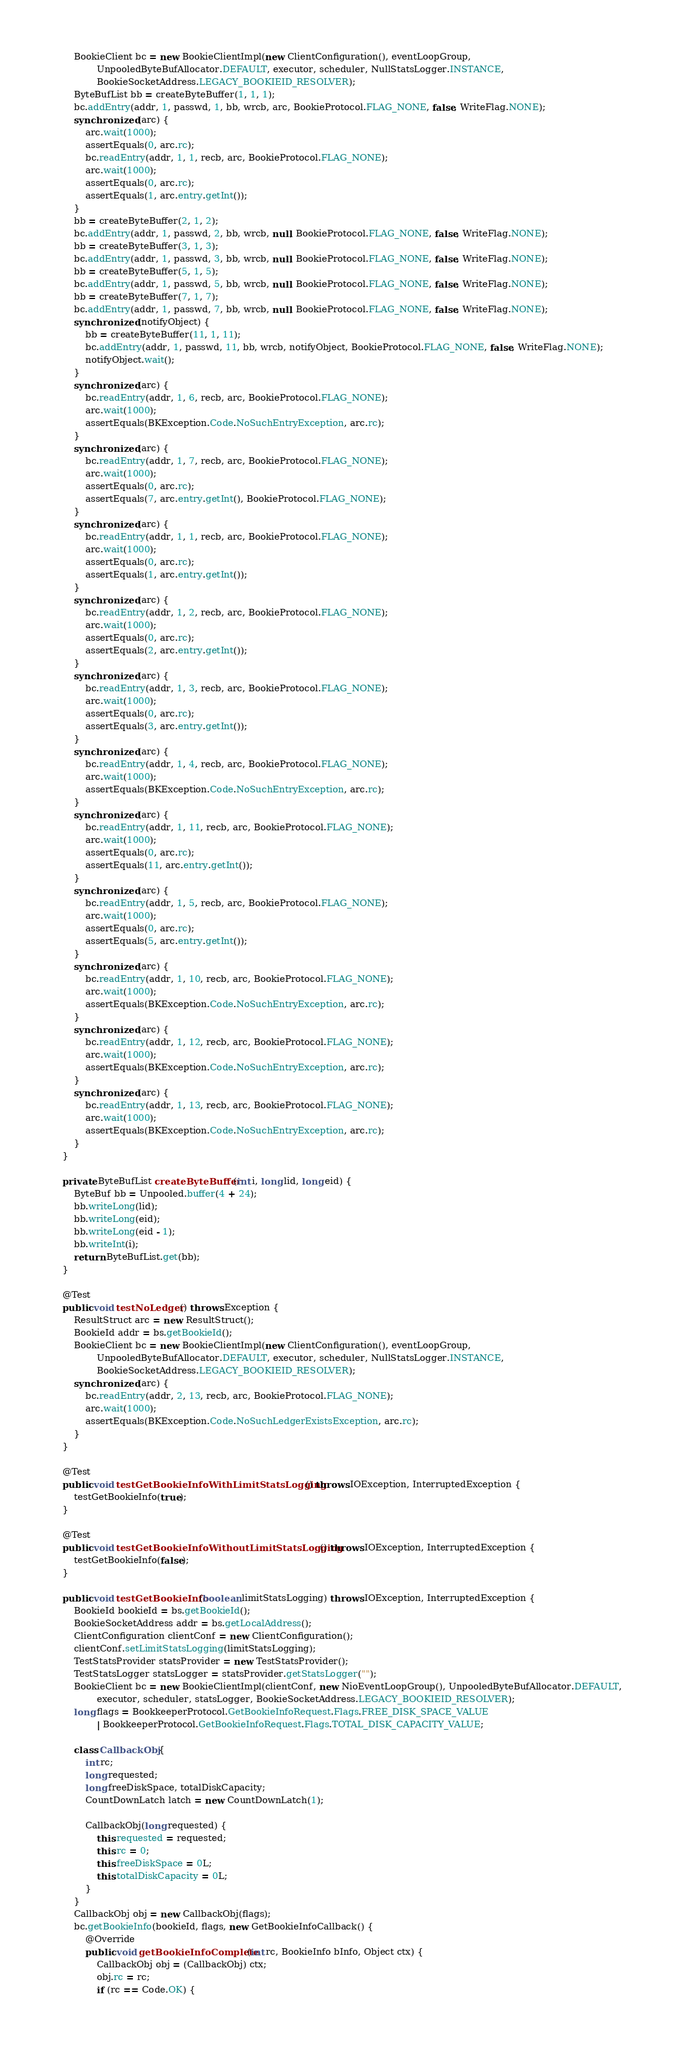Convert code to text. <code><loc_0><loc_0><loc_500><loc_500><_Java_>
        BookieClient bc = new BookieClientImpl(new ClientConfiguration(), eventLoopGroup,
                UnpooledByteBufAllocator.DEFAULT, executor, scheduler, NullStatsLogger.INSTANCE,
                BookieSocketAddress.LEGACY_BOOKIEID_RESOLVER);
        ByteBufList bb = createByteBuffer(1, 1, 1);
        bc.addEntry(addr, 1, passwd, 1, bb, wrcb, arc, BookieProtocol.FLAG_NONE, false, WriteFlag.NONE);
        synchronized (arc) {
            arc.wait(1000);
            assertEquals(0, arc.rc);
            bc.readEntry(addr, 1, 1, recb, arc, BookieProtocol.FLAG_NONE);
            arc.wait(1000);
            assertEquals(0, arc.rc);
            assertEquals(1, arc.entry.getInt());
        }
        bb = createByteBuffer(2, 1, 2);
        bc.addEntry(addr, 1, passwd, 2, bb, wrcb, null, BookieProtocol.FLAG_NONE, false, WriteFlag.NONE);
        bb = createByteBuffer(3, 1, 3);
        bc.addEntry(addr, 1, passwd, 3, bb, wrcb, null, BookieProtocol.FLAG_NONE, false, WriteFlag.NONE);
        bb = createByteBuffer(5, 1, 5);
        bc.addEntry(addr, 1, passwd, 5, bb, wrcb, null, BookieProtocol.FLAG_NONE, false, WriteFlag.NONE);
        bb = createByteBuffer(7, 1, 7);
        bc.addEntry(addr, 1, passwd, 7, bb, wrcb, null, BookieProtocol.FLAG_NONE, false, WriteFlag.NONE);
        synchronized (notifyObject) {
            bb = createByteBuffer(11, 1, 11);
            bc.addEntry(addr, 1, passwd, 11, bb, wrcb, notifyObject, BookieProtocol.FLAG_NONE, false, WriteFlag.NONE);
            notifyObject.wait();
        }
        synchronized (arc) {
            bc.readEntry(addr, 1, 6, recb, arc, BookieProtocol.FLAG_NONE);
            arc.wait(1000);
            assertEquals(BKException.Code.NoSuchEntryException, arc.rc);
        }
        synchronized (arc) {
            bc.readEntry(addr, 1, 7, recb, arc, BookieProtocol.FLAG_NONE);
            arc.wait(1000);
            assertEquals(0, arc.rc);
            assertEquals(7, arc.entry.getInt(), BookieProtocol.FLAG_NONE);
        }
        synchronized (arc) {
            bc.readEntry(addr, 1, 1, recb, arc, BookieProtocol.FLAG_NONE);
            arc.wait(1000);
            assertEquals(0, arc.rc);
            assertEquals(1, arc.entry.getInt());
        }
        synchronized (arc) {
            bc.readEntry(addr, 1, 2, recb, arc, BookieProtocol.FLAG_NONE);
            arc.wait(1000);
            assertEquals(0, arc.rc);
            assertEquals(2, arc.entry.getInt());
        }
        synchronized (arc) {
            bc.readEntry(addr, 1, 3, recb, arc, BookieProtocol.FLAG_NONE);
            arc.wait(1000);
            assertEquals(0, arc.rc);
            assertEquals(3, arc.entry.getInt());
        }
        synchronized (arc) {
            bc.readEntry(addr, 1, 4, recb, arc, BookieProtocol.FLAG_NONE);
            arc.wait(1000);
            assertEquals(BKException.Code.NoSuchEntryException, arc.rc);
        }
        synchronized (arc) {
            bc.readEntry(addr, 1, 11, recb, arc, BookieProtocol.FLAG_NONE);
            arc.wait(1000);
            assertEquals(0, arc.rc);
            assertEquals(11, arc.entry.getInt());
        }
        synchronized (arc) {
            bc.readEntry(addr, 1, 5, recb, arc, BookieProtocol.FLAG_NONE);
            arc.wait(1000);
            assertEquals(0, arc.rc);
            assertEquals(5, arc.entry.getInt());
        }
        synchronized (arc) {
            bc.readEntry(addr, 1, 10, recb, arc, BookieProtocol.FLAG_NONE);
            arc.wait(1000);
            assertEquals(BKException.Code.NoSuchEntryException, arc.rc);
        }
        synchronized (arc) {
            bc.readEntry(addr, 1, 12, recb, arc, BookieProtocol.FLAG_NONE);
            arc.wait(1000);
            assertEquals(BKException.Code.NoSuchEntryException, arc.rc);
        }
        synchronized (arc) {
            bc.readEntry(addr, 1, 13, recb, arc, BookieProtocol.FLAG_NONE);
            arc.wait(1000);
            assertEquals(BKException.Code.NoSuchEntryException, arc.rc);
        }
    }

    private ByteBufList createByteBuffer(int i, long lid, long eid) {
        ByteBuf bb = Unpooled.buffer(4 + 24);
        bb.writeLong(lid);
        bb.writeLong(eid);
        bb.writeLong(eid - 1);
        bb.writeInt(i);
        return ByteBufList.get(bb);
    }

    @Test
    public void testNoLedger() throws Exception {
        ResultStruct arc = new ResultStruct();
        BookieId addr = bs.getBookieId();
        BookieClient bc = new BookieClientImpl(new ClientConfiguration(), eventLoopGroup,
                UnpooledByteBufAllocator.DEFAULT, executor, scheduler, NullStatsLogger.INSTANCE,
                BookieSocketAddress.LEGACY_BOOKIEID_RESOLVER);
        synchronized (arc) {
            bc.readEntry(addr, 2, 13, recb, arc, BookieProtocol.FLAG_NONE);
            arc.wait(1000);
            assertEquals(BKException.Code.NoSuchLedgerExistsException, arc.rc);
        }
    }

    @Test
    public void testGetBookieInfoWithLimitStatsLogging() throws IOException, InterruptedException {
        testGetBookieInfo(true);
    }

    @Test
    public void testGetBookieInfoWithoutLimitStatsLogging() throws IOException, InterruptedException {
        testGetBookieInfo(false);
    }

    public void testGetBookieInfo(boolean limitStatsLogging) throws IOException, InterruptedException {
        BookieId bookieId = bs.getBookieId();
        BookieSocketAddress addr = bs.getLocalAddress();
        ClientConfiguration clientConf = new ClientConfiguration();
        clientConf.setLimitStatsLogging(limitStatsLogging);
        TestStatsProvider statsProvider = new TestStatsProvider();
        TestStatsLogger statsLogger = statsProvider.getStatsLogger("");
        BookieClient bc = new BookieClientImpl(clientConf, new NioEventLoopGroup(), UnpooledByteBufAllocator.DEFAULT,
                executor, scheduler, statsLogger, BookieSocketAddress.LEGACY_BOOKIEID_RESOLVER);
        long flags = BookkeeperProtocol.GetBookieInfoRequest.Flags.FREE_DISK_SPACE_VALUE
                | BookkeeperProtocol.GetBookieInfoRequest.Flags.TOTAL_DISK_CAPACITY_VALUE;

        class CallbackObj {
            int rc;
            long requested;
            long freeDiskSpace, totalDiskCapacity;
            CountDownLatch latch = new CountDownLatch(1);

            CallbackObj(long requested) {
                this.requested = requested;
                this.rc = 0;
                this.freeDiskSpace = 0L;
                this.totalDiskCapacity = 0L;
            }
        }
        CallbackObj obj = new CallbackObj(flags);
        bc.getBookieInfo(bookieId, flags, new GetBookieInfoCallback() {
            @Override
            public void getBookieInfoComplete(int rc, BookieInfo bInfo, Object ctx) {
                CallbackObj obj = (CallbackObj) ctx;
                obj.rc = rc;
                if (rc == Code.OK) {</code> 